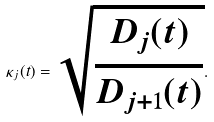<formula> <loc_0><loc_0><loc_500><loc_500>\kappa _ { j } ( t ) = \sqrt { \frac { D _ { j } ( t ) } { D _ { j + 1 } ( t ) } } .</formula> 